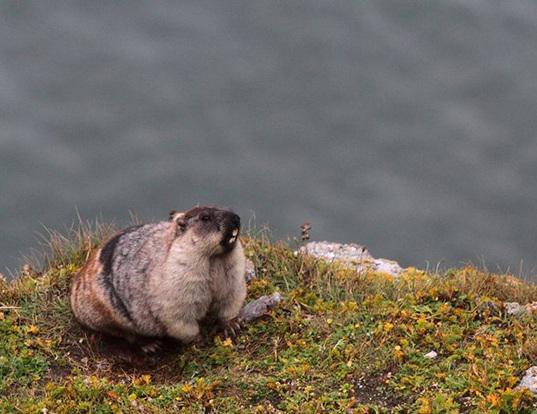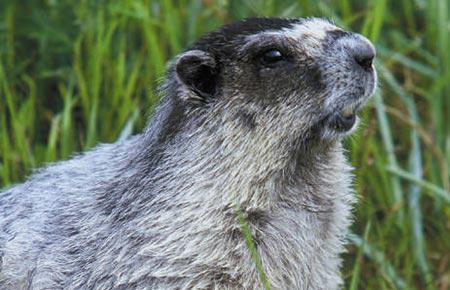The first image is the image on the left, the second image is the image on the right. Given the left and right images, does the statement "The animals in the image on the left are on a rocky peak." hold true? Answer yes or no. No. The first image is the image on the left, the second image is the image on the right. Assess this claim about the two images: "The marmot in the left image is looking in the direction of the camera". Correct or not? Answer yes or no. No. 